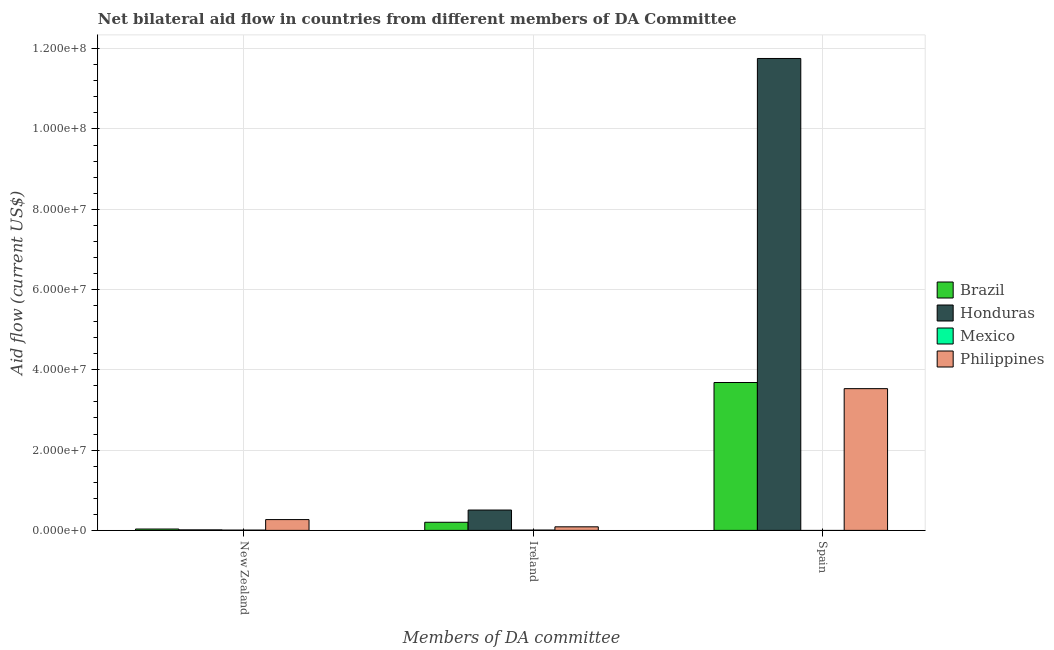How many groups of bars are there?
Keep it short and to the point. 3. Are the number of bars on each tick of the X-axis equal?
Give a very brief answer. No. What is the label of the 1st group of bars from the left?
Your response must be concise. New Zealand. What is the amount of aid provided by new zealand in Brazil?
Make the answer very short. 3.40e+05. Across all countries, what is the maximum amount of aid provided by new zealand?
Make the answer very short. 2.69e+06. Across all countries, what is the minimum amount of aid provided by spain?
Give a very brief answer. 0. In which country was the amount of aid provided by new zealand maximum?
Make the answer very short. Philippines. What is the total amount of aid provided by ireland in the graph?
Provide a succinct answer. 8.06e+06. What is the difference between the amount of aid provided by new zealand in Honduras and that in Brazil?
Provide a short and direct response. -2.10e+05. What is the difference between the amount of aid provided by new zealand in Brazil and the amount of aid provided by spain in Honduras?
Provide a short and direct response. -1.17e+08. What is the average amount of aid provided by spain per country?
Provide a short and direct response. 4.74e+07. What is the difference between the amount of aid provided by ireland and amount of aid provided by new zealand in Philippines?
Offer a very short reply. -1.80e+06. In how many countries, is the amount of aid provided by ireland greater than 16000000 US$?
Provide a short and direct response. 0. What is the ratio of the amount of aid provided by new zealand in Honduras to that in Brazil?
Offer a terse response. 0.38. Is the difference between the amount of aid provided by new zealand in Mexico and Philippines greater than the difference between the amount of aid provided by ireland in Mexico and Philippines?
Provide a short and direct response. No. What is the difference between the highest and the second highest amount of aid provided by spain?
Provide a succinct answer. 8.07e+07. What is the difference between the highest and the lowest amount of aid provided by spain?
Offer a very short reply. 1.18e+08. In how many countries, is the amount of aid provided by ireland greater than the average amount of aid provided by ireland taken over all countries?
Make the answer very short. 2. How many bars are there?
Ensure brevity in your answer.  11. Are all the bars in the graph horizontal?
Keep it short and to the point. No. How many countries are there in the graph?
Provide a succinct answer. 4. Are the values on the major ticks of Y-axis written in scientific E-notation?
Your answer should be compact. Yes. Does the graph contain any zero values?
Your response must be concise. Yes. What is the title of the graph?
Offer a terse response. Net bilateral aid flow in countries from different members of DA Committee. Does "Namibia" appear as one of the legend labels in the graph?
Ensure brevity in your answer.  No. What is the label or title of the X-axis?
Keep it short and to the point. Members of DA committee. What is the label or title of the Y-axis?
Your response must be concise. Aid flow (current US$). What is the Aid flow (current US$) in Mexico in New Zealand?
Offer a very short reply. 7.00e+04. What is the Aid flow (current US$) of Philippines in New Zealand?
Ensure brevity in your answer.  2.69e+06. What is the Aid flow (current US$) of Brazil in Ireland?
Give a very brief answer. 2.02e+06. What is the Aid flow (current US$) of Honduras in Ireland?
Offer a terse response. 5.07e+06. What is the Aid flow (current US$) of Philippines in Ireland?
Offer a terse response. 8.90e+05. What is the Aid flow (current US$) in Brazil in Spain?
Your answer should be very brief. 3.68e+07. What is the Aid flow (current US$) of Honduras in Spain?
Offer a terse response. 1.18e+08. What is the Aid flow (current US$) in Philippines in Spain?
Make the answer very short. 3.53e+07. Across all Members of DA committee, what is the maximum Aid flow (current US$) of Brazil?
Your answer should be very brief. 3.68e+07. Across all Members of DA committee, what is the maximum Aid flow (current US$) of Honduras?
Offer a terse response. 1.18e+08. Across all Members of DA committee, what is the maximum Aid flow (current US$) in Mexico?
Ensure brevity in your answer.  8.00e+04. Across all Members of DA committee, what is the maximum Aid flow (current US$) of Philippines?
Your answer should be compact. 3.53e+07. Across all Members of DA committee, what is the minimum Aid flow (current US$) of Honduras?
Offer a very short reply. 1.30e+05. Across all Members of DA committee, what is the minimum Aid flow (current US$) in Philippines?
Ensure brevity in your answer.  8.90e+05. What is the total Aid flow (current US$) of Brazil in the graph?
Provide a short and direct response. 3.92e+07. What is the total Aid flow (current US$) in Honduras in the graph?
Provide a short and direct response. 1.23e+08. What is the total Aid flow (current US$) of Mexico in the graph?
Give a very brief answer. 1.50e+05. What is the total Aid flow (current US$) of Philippines in the graph?
Make the answer very short. 3.89e+07. What is the difference between the Aid flow (current US$) of Brazil in New Zealand and that in Ireland?
Offer a very short reply. -1.68e+06. What is the difference between the Aid flow (current US$) in Honduras in New Zealand and that in Ireland?
Your response must be concise. -4.94e+06. What is the difference between the Aid flow (current US$) of Mexico in New Zealand and that in Ireland?
Offer a terse response. -10000. What is the difference between the Aid flow (current US$) of Philippines in New Zealand and that in Ireland?
Your response must be concise. 1.80e+06. What is the difference between the Aid flow (current US$) in Brazil in New Zealand and that in Spain?
Offer a very short reply. -3.65e+07. What is the difference between the Aid flow (current US$) of Honduras in New Zealand and that in Spain?
Make the answer very short. -1.17e+08. What is the difference between the Aid flow (current US$) in Philippines in New Zealand and that in Spain?
Give a very brief answer. -3.26e+07. What is the difference between the Aid flow (current US$) of Brazil in Ireland and that in Spain?
Provide a succinct answer. -3.48e+07. What is the difference between the Aid flow (current US$) in Honduras in Ireland and that in Spain?
Provide a succinct answer. -1.12e+08. What is the difference between the Aid flow (current US$) in Philippines in Ireland and that in Spain?
Ensure brevity in your answer.  -3.44e+07. What is the difference between the Aid flow (current US$) in Brazil in New Zealand and the Aid flow (current US$) in Honduras in Ireland?
Give a very brief answer. -4.73e+06. What is the difference between the Aid flow (current US$) in Brazil in New Zealand and the Aid flow (current US$) in Mexico in Ireland?
Your response must be concise. 2.60e+05. What is the difference between the Aid flow (current US$) of Brazil in New Zealand and the Aid flow (current US$) of Philippines in Ireland?
Your answer should be very brief. -5.50e+05. What is the difference between the Aid flow (current US$) of Honduras in New Zealand and the Aid flow (current US$) of Philippines in Ireland?
Provide a short and direct response. -7.60e+05. What is the difference between the Aid flow (current US$) in Mexico in New Zealand and the Aid flow (current US$) in Philippines in Ireland?
Your answer should be compact. -8.20e+05. What is the difference between the Aid flow (current US$) in Brazil in New Zealand and the Aid flow (current US$) in Honduras in Spain?
Your answer should be very brief. -1.17e+08. What is the difference between the Aid flow (current US$) in Brazil in New Zealand and the Aid flow (current US$) in Philippines in Spain?
Your answer should be compact. -3.50e+07. What is the difference between the Aid flow (current US$) of Honduras in New Zealand and the Aid flow (current US$) of Philippines in Spain?
Your response must be concise. -3.52e+07. What is the difference between the Aid flow (current US$) in Mexico in New Zealand and the Aid flow (current US$) in Philippines in Spain?
Your response must be concise. -3.52e+07. What is the difference between the Aid flow (current US$) of Brazil in Ireland and the Aid flow (current US$) of Honduras in Spain?
Ensure brevity in your answer.  -1.16e+08. What is the difference between the Aid flow (current US$) in Brazil in Ireland and the Aid flow (current US$) in Philippines in Spain?
Give a very brief answer. -3.33e+07. What is the difference between the Aid flow (current US$) in Honduras in Ireland and the Aid flow (current US$) in Philippines in Spain?
Ensure brevity in your answer.  -3.02e+07. What is the difference between the Aid flow (current US$) of Mexico in Ireland and the Aid flow (current US$) of Philippines in Spain?
Ensure brevity in your answer.  -3.52e+07. What is the average Aid flow (current US$) in Brazil per Members of DA committee?
Offer a very short reply. 1.31e+07. What is the average Aid flow (current US$) in Honduras per Members of DA committee?
Keep it short and to the point. 4.09e+07. What is the average Aid flow (current US$) in Philippines per Members of DA committee?
Your answer should be compact. 1.30e+07. What is the difference between the Aid flow (current US$) of Brazil and Aid flow (current US$) of Mexico in New Zealand?
Provide a succinct answer. 2.70e+05. What is the difference between the Aid flow (current US$) of Brazil and Aid flow (current US$) of Philippines in New Zealand?
Keep it short and to the point. -2.35e+06. What is the difference between the Aid flow (current US$) of Honduras and Aid flow (current US$) of Philippines in New Zealand?
Give a very brief answer. -2.56e+06. What is the difference between the Aid flow (current US$) in Mexico and Aid flow (current US$) in Philippines in New Zealand?
Give a very brief answer. -2.62e+06. What is the difference between the Aid flow (current US$) in Brazil and Aid flow (current US$) in Honduras in Ireland?
Offer a terse response. -3.05e+06. What is the difference between the Aid flow (current US$) in Brazil and Aid flow (current US$) in Mexico in Ireland?
Offer a very short reply. 1.94e+06. What is the difference between the Aid flow (current US$) in Brazil and Aid flow (current US$) in Philippines in Ireland?
Offer a terse response. 1.13e+06. What is the difference between the Aid flow (current US$) in Honduras and Aid flow (current US$) in Mexico in Ireland?
Your response must be concise. 4.99e+06. What is the difference between the Aid flow (current US$) of Honduras and Aid flow (current US$) of Philippines in Ireland?
Keep it short and to the point. 4.18e+06. What is the difference between the Aid flow (current US$) of Mexico and Aid flow (current US$) of Philippines in Ireland?
Provide a succinct answer. -8.10e+05. What is the difference between the Aid flow (current US$) in Brazil and Aid flow (current US$) in Honduras in Spain?
Your answer should be very brief. -8.07e+07. What is the difference between the Aid flow (current US$) in Brazil and Aid flow (current US$) in Philippines in Spain?
Your answer should be very brief. 1.53e+06. What is the difference between the Aid flow (current US$) in Honduras and Aid flow (current US$) in Philippines in Spain?
Give a very brief answer. 8.22e+07. What is the ratio of the Aid flow (current US$) of Brazil in New Zealand to that in Ireland?
Offer a terse response. 0.17. What is the ratio of the Aid flow (current US$) of Honduras in New Zealand to that in Ireland?
Your answer should be very brief. 0.03. What is the ratio of the Aid flow (current US$) of Mexico in New Zealand to that in Ireland?
Your answer should be very brief. 0.88. What is the ratio of the Aid flow (current US$) in Philippines in New Zealand to that in Ireland?
Offer a terse response. 3.02. What is the ratio of the Aid flow (current US$) in Brazil in New Zealand to that in Spain?
Give a very brief answer. 0.01. What is the ratio of the Aid flow (current US$) of Honduras in New Zealand to that in Spain?
Keep it short and to the point. 0. What is the ratio of the Aid flow (current US$) of Philippines in New Zealand to that in Spain?
Your answer should be compact. 0.08. What is the ratio of the Aid flow (current US$) of Brazil in Ireland to that in Spain?
Make the answer very short. 0.05. What is the ratio of the Aid flow (current US$) of Honduras in Ireland to that in Spain?
Your answer should be very brief. 0.04. What is the ratio of the Aid flow (current US$) in Philippines in Ireland to that in Spain?
Offer a terse response. 0.03. What is the difference between the highest and the second highest Aid flow (current US$) of Brazil?
Your answer should be compact. 3.48e+07. What is the difference between the highest and the second highest Aid flow (current US$) of Honduras?
Provide a short and direct response. 1.12e+08. What is the difference between the highest and the second highest Aid flow (current US$) in Philippines?
Your response must be concise. 3.26e+07. What is the difference between the highest and the lowest Aid flow (current US$) in Brazil?
Ensure brevity in your answer.  3.65e+07. What is the difference between the highest and the lowest Aid flow (current US$) in Honduras?
Provide a short and direct response. 1.17e+08. What is the difference between the highest and the lowest Aid flow (current US$) in Mexico?
Provide a succinct answer. 8.00e+04. What is the difference between the highest and the lowest Aid flow (current US$) of Philippines?
Ensure brevity in your answer.  3.44e+07. 